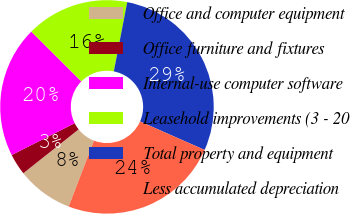<chart> <loc_0><loc_0><loc_500><loc_500><pie_chart><fcel>Office and computer equipment<fcel>Office furniture and fixtures<fcel>Internal-use computer software<fcel>Leasehold improvements (3 - 20<fcel>Total property and equipment<fcel>Less accumulated depreciation<nl><fcel>8.49%<fcel>3.23%<fcel>19.9%<fcel>15.57%<fcel>28.56%<fcel>24.23%<nl></chart> 